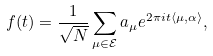Convert formula to latex. <formula><loc_0><loc_0><loc_500><loc_500>f ( t ) = \frac { 1 } { \sqrt { N } } \sum _ { \mu \in \mathcal { E } } a _ { \mu } e ^ { 2 \pi i t \langle \mu , \alpha \rangle } ,</formula> 